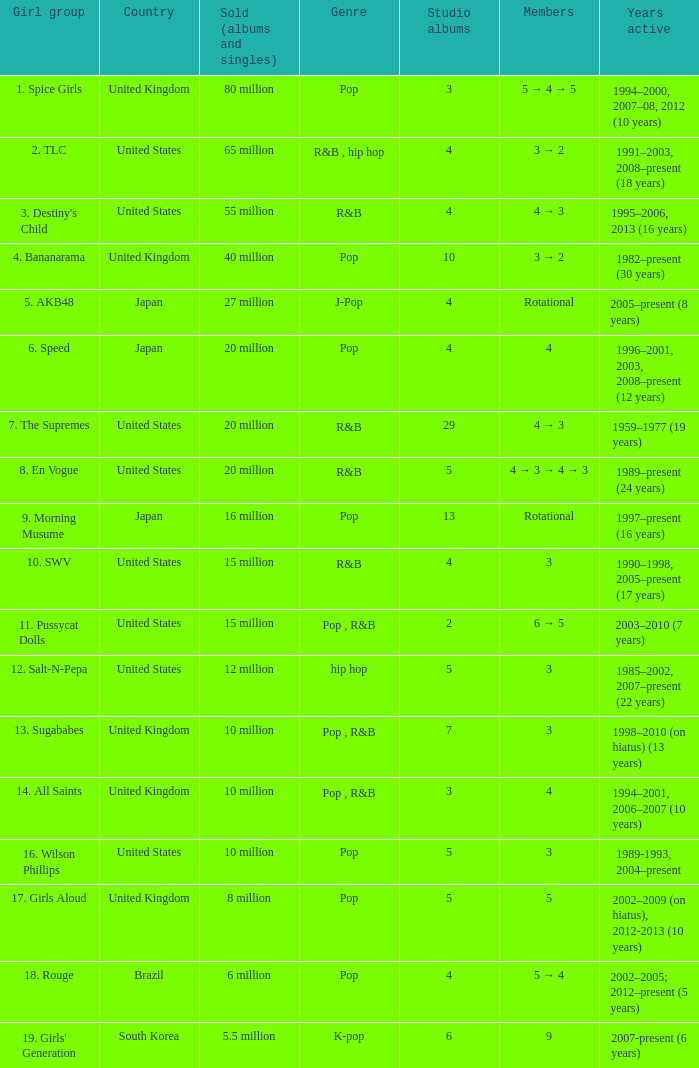In the group that sold 65 million albums and singles, how many individuals were there? 3 → 2. Would you be able to parse every entry in this table? {'header': ['Girl group', 'Country', 'Sold (albums and singles)', 'Genre', 'Studio albums', 'Members', 'Years active'], 'rows': [['1. Spice Girls', 'United Kingdom', '80 million', 'Pop', '3', '5 → 4 → 5', '1994–2000, 2007–08, 2012 (10 years)'], ['2. TLC', 'United States', '65 million', 'R&B , hip hop', '4', '3 → 2', '1991–2003, 2008–present (18 years)'], ["3. Destiny's Child", 'United States', '55 million', 'R&B', '4', '4 → 3', '1995–2006, 2013 (16 years)'], ['4. Bananarama', 'United Kingdom', '40 million', 'Pop', '10', '3 → 2', '1982–present (30 years)'], ['5. AKB48', 'Japan', '27 million', 'J-Pop', '4', 'Rotational', '2005–present (8 years)'], ['6. Speed', 'Japan', '20 million', 'Pop', '4', '4', '1996–2001, 2003, 2008–present (12 years)'], ['7. The Supremes', 'United States', '20 million', 'R&B', '29', '4 → 3', '1959–1977 (19 years)'], ['8. En Vogue', 'United States', '20 million', 'R&B', '5', '4 → 3 → 4 → 3', '1989–present (24 years)'], ['9. Morning Musume', 'Japan', '16 million', 'Pop', '13', 'Rotational', '1997–present (16 years)'], ['10. SWV', 'United States', '15 million', 'R&B', '4', '3', '1990–1998, 2005–present (17 years)'], ['11. Pussycat Dolls', 'United States', '15 million', 'Pop , R&B', '2', '6 → 5', '2003–2010 (7 years)'], ['12. Salt-N-Pepa', 'United States', '12 million', 'hip hop', '5', '3', '1985–2002, 2007–present (22 years)'], ['13. Sugababes', 'United Kingdom', '10 million', 'Pop , R&B', '7', '3', '1998–2010 (on hiatus) (13 years)'], ['14. All Saints', 'United Kingdom', '10 million', 'Pop , R&B', '3', '4', '1994–2001, 2006–2007 (10 years)'], ['16. Wilson Phillips', 'United States', '10 million', 'Pop', '5', '3', '1989-1993, 2004–present'], ['17. Girls Aloud', 'United Kingdom', '8 million', 'Pop', '5', '5', '2002–2009 (on hiatus), 2012-2013 (10 years)'], ['18. Rouge', 'Brazil', '6 million', 'Pop', '4', '5 → 4', '2002–2005; 2012–present (5 years)'], ["19. Girls' Generation", 'South Korea', '5.5 million', 'K-pop', '6', '9', '2007-present (6 years)']]} 